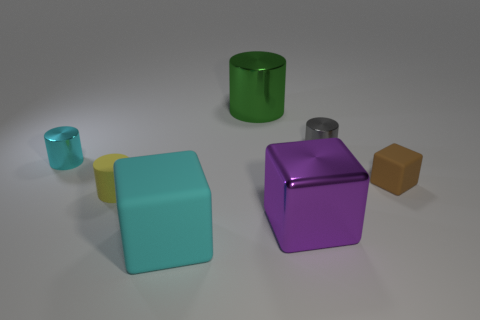The tiny brown rubber object is what shape?
Your answer should be compact. Cube. What shape is the metallic object that is both behind the matte cylinder and in front of the small gray cylinder?
Make the answer very short. Cylinder. There is another large cylinder that is made of the same material as the cyan cylinder; what is its color?
Keep it short and to the point. Green. What shape is the cyan thing that is behind the matte cube left of the small metallic cylinder that is right of the purple metallic cube?
Ensure brevity in your answer.  Cylinder. What is the size of the rubber cylinder?
Offer a terse response. Small. What shape is the purple thing that is the same material as the gray cylinder?
Your answer should be compact. Cube. Are there fewer objects that are in front of the small matte cube than tiny red matte spheres?
Give a very brief answer. No. What is the color of the small metallic thing to the right of the large cyan rubber thing?
Your answer should be very brief. Gray. There is another thing that is the same color as the large rubber object; what is it made of?
Your answer should be very brief. Metal. Are there any small objects that have the same shape as the big green metal thing?
Your response must be concise. Yes. 